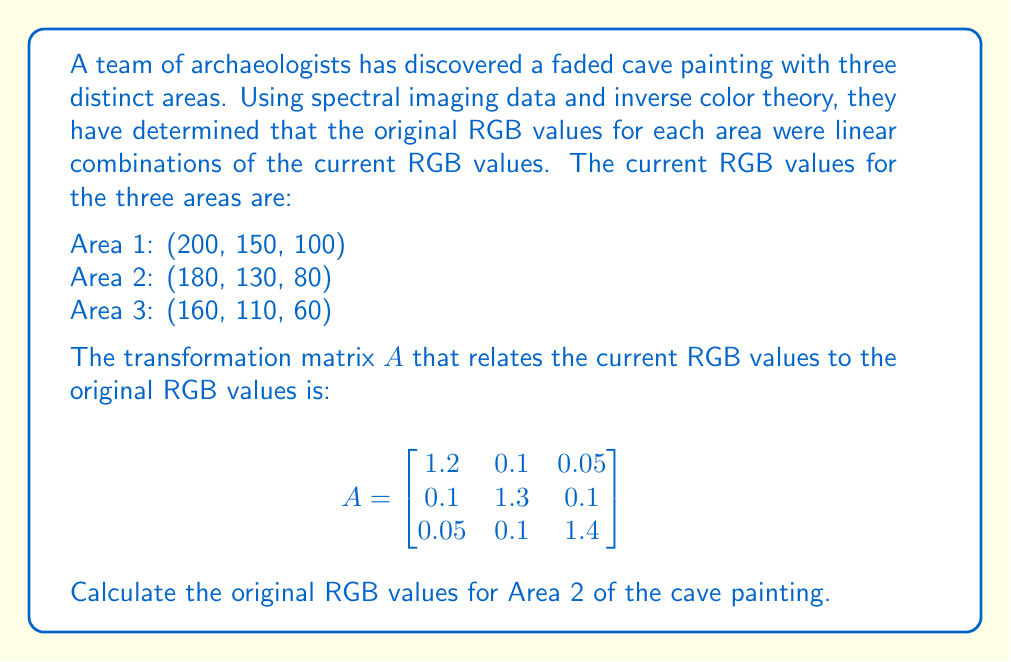Give your solution to this math problem. To solve this inverse problem and determine the original RGB values, we need to use the given transformation matrix $A$ and the current RGB values for Area 2.

Step 1: Set up the equation
Let $x = (r, g, b)^T$ be the original RGB values we're looking for, and $y = (180, 130, 80)^T$ be the current RGB values for Area 2. The relationship between these is:

$$Ax = y$$

Step 2: Solve for x by inverting the matrix A
We need to calculate $x = A^{-1}y$

First, let's calculate $A^{-1}$:

$$A^{-1} = \frac{1}{det(A)}\begin{bmatrix}
1.82 & -0.14 & -0.07 \\
-0.14 & 1.71 & -0.13 \\
-0.07 & -0.13 & 1.71
\end{bmatrix}$$

Where $det(A) = 2.1164$

Step 3: Multiply $A^{-1}$ by $y$

$$x = A^{-1}y = \frac{1}{2.1164}\begin{bmatrix}
1.82 & -0.14 & -0.07 \\
-0.14 & 1.71 & -0.13 \\
-0.07 & -0.13 & 1.71
\end{bmatrix} \begin{bmatrix}
180 \\
130 \\
80
\end{bmatrix}$$

Step 4: Perform the matrix multiplication

$$x = \begin{bmatrix}
(1.82 * 180 + (-0.14) * 130 + (-0.07) * 80) / 2.1164 \\
((-0.14) * 180 + 1.71 * 130 + (-0.13) * 80) / 2.1164 \\
((-0.07) * 180 + (-0.13) * 130 + 1.71 * 80) / 2.1164
\end{bmatrix}$$

Step 5: Calculate the final values

$$x = \begin{bmatrix}
149.98 \\
99.97 \\
56.99
\end{bmatrix}$$

Rounding to the nearest integer (as RGB values are typically integers):

$$x = \begin{bmatrix}
150 \\
100 \\
57
\end{bmatrix}$$
Answer: (150, 100, 57) 